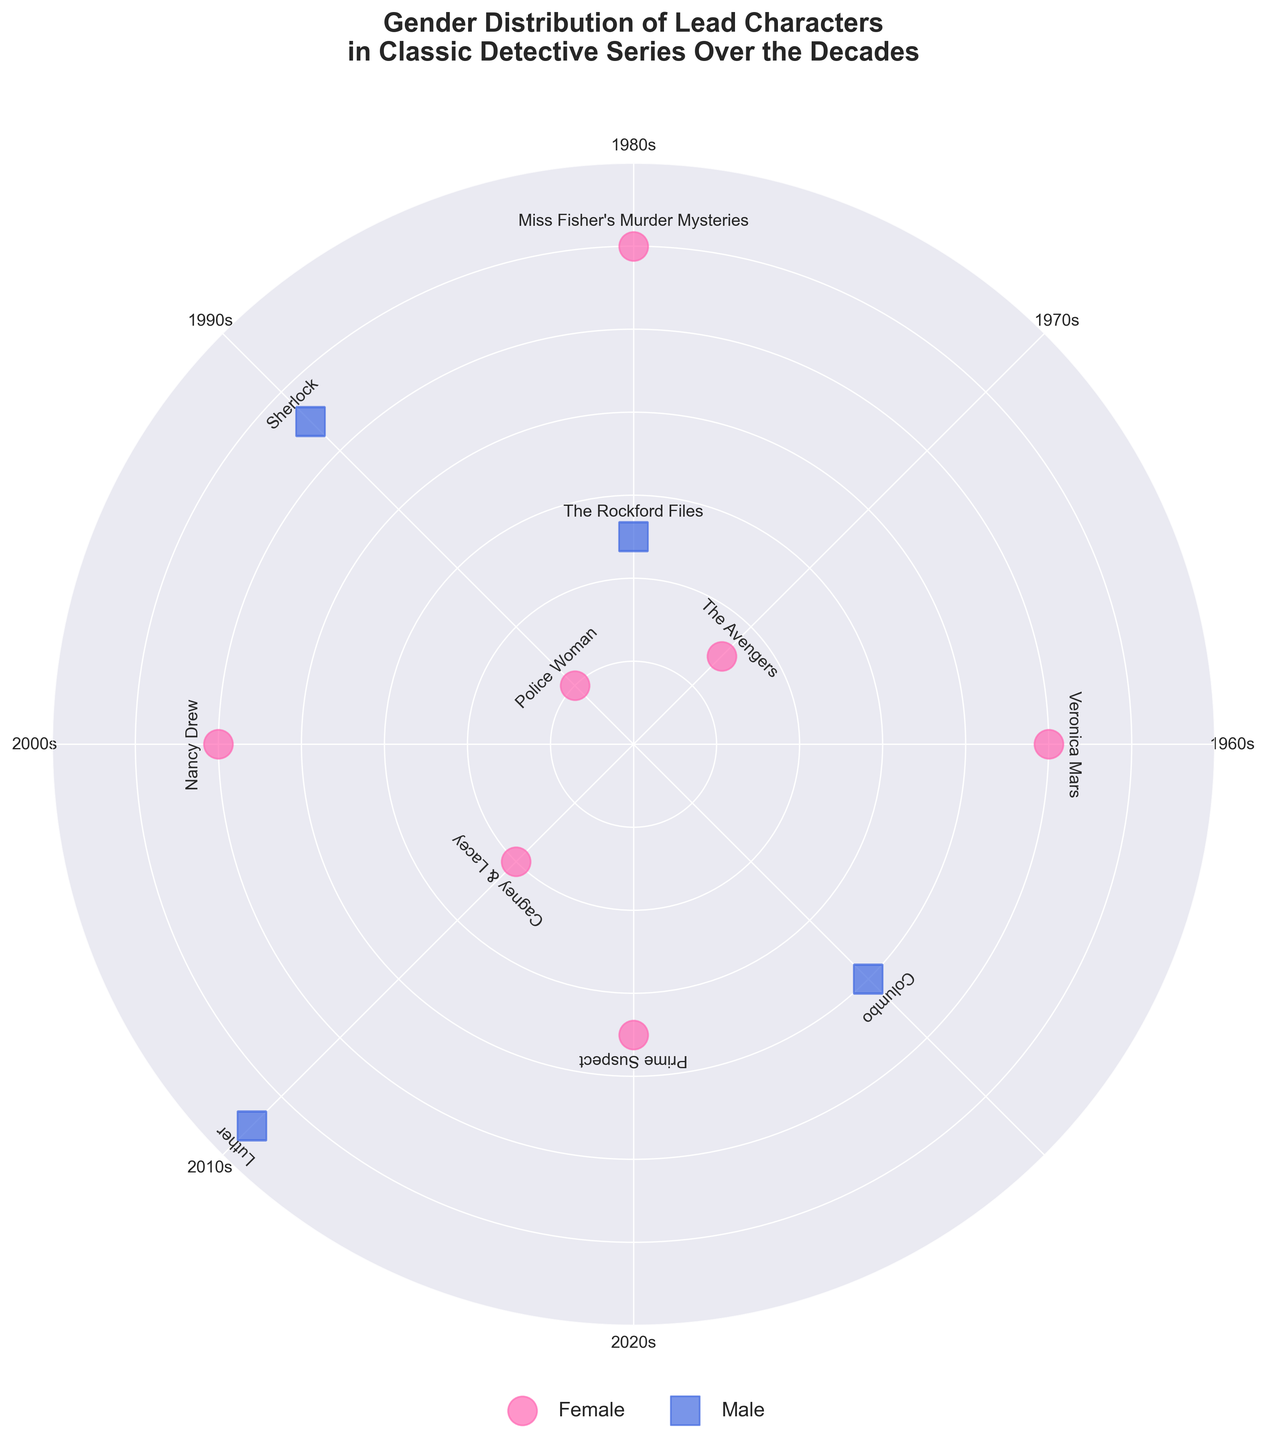What's the title of the figure? The title is found at the top of the figure in bold text. It reads "Gender Distribution of Lead Characters in Classic Detective Series Over the Decades".
Answer: Gender Distribution of Lead Characters in Classic Detective Series Over the Decades How many female-led detective series are depicted in the 2010s? To answer this, locate the decade label for the 2010s, then count the number of female series markers ('o') within its range of angles (90 to 135 degrees). There is one marker ('Miss Fisher's Murder Mysteries' at 90 degrees).
Answer: 1 Which decade has the highest radius for a female-led series? Look for the marker corresponding to female-led series ('o') and find the one with the highest radius value. This is in the 2010s with "Miss Fisher's Murder Mysteries" having a radius of 60.
Answer: 2010s What is the difference in radius between the female-led series in the 1960s and the 1990s? Find the radius for the series in the 1960s ("The Avengers", radius 15) and the 1990s ("Prime Suspect", radius 35). Subtract the smaller radius from the larger radius: 35 - 15 = 20.
Answer: 20 Which male-led series has the largest radius? Look for the square markers ('s') indicating male-led series and identify the one with the largest radius. "Luther" in the 2020s has the largest radius of 65.
Answer: Luther How many series are plotted in total on the chart? Count all the data points on the plot. There are 11 data points representing different series.
Answer: 11 During which decade do both male and female lead series have the closest radius values? Compare the radius values of male and female series in each decade. In the 2020s, "Nancy Drew" (50) and "Luther" (65), the difference is 15 which is relatively close compared to other decades.
Answer: 2020s What is the average radius of female-led series? Sum all the radius values of the female-led series and divide by the number of these series. The radii are 15 (1960s), 10 (1970s), 20 (1980s), 35 (1990s), 50 (2000s), 60 (2010s), and 50 (2020s). The sum is 240, and there are 7 series: 240 / 7 ≈ 34.29.
Answer: 34.29 What series is plotted at the angle of 45 degrees? Locate the data point plotted at 45 degrees. The series at this angle is "The Avengers".
Answer: The Avengers 